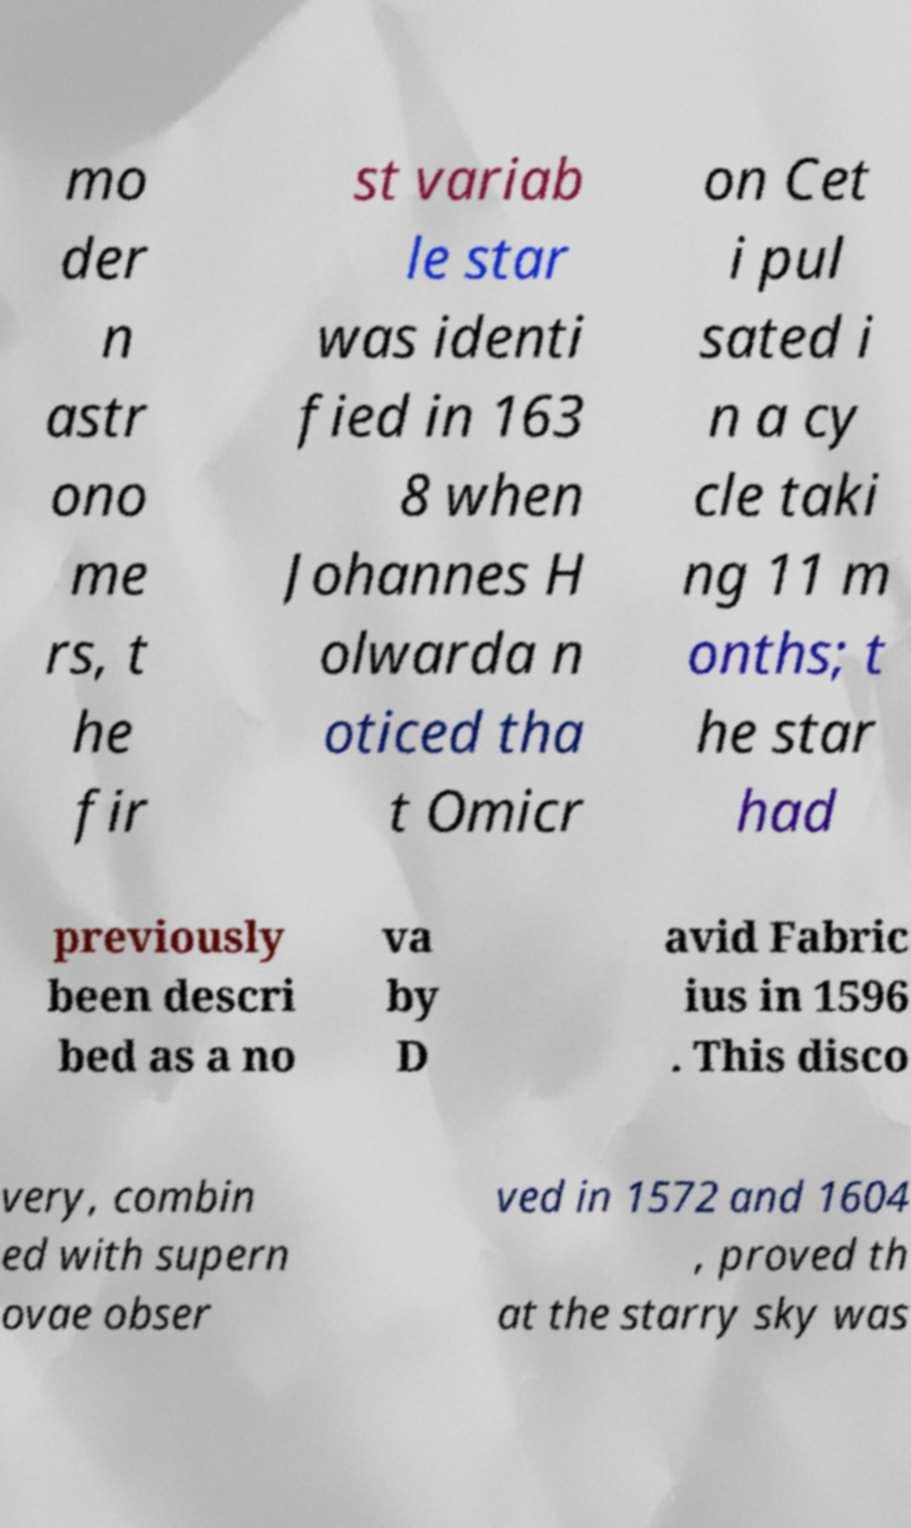Can you accurately transcribe the text from the provided image for me? mo der n astr ono me rs, t he fir st variab le star was identi fied in 163 8 when Johannes H olwarda n oticed tha t Omicr on Cet i pul sated i n a cy cle taki ng 11 m onths; t he star had previously been descri bed as a no va by D avid Fabric ius in 1596 . This disco very, combin ed with supern ovae obser ved in 1572 and 1604 , proved th at the starry sky was 